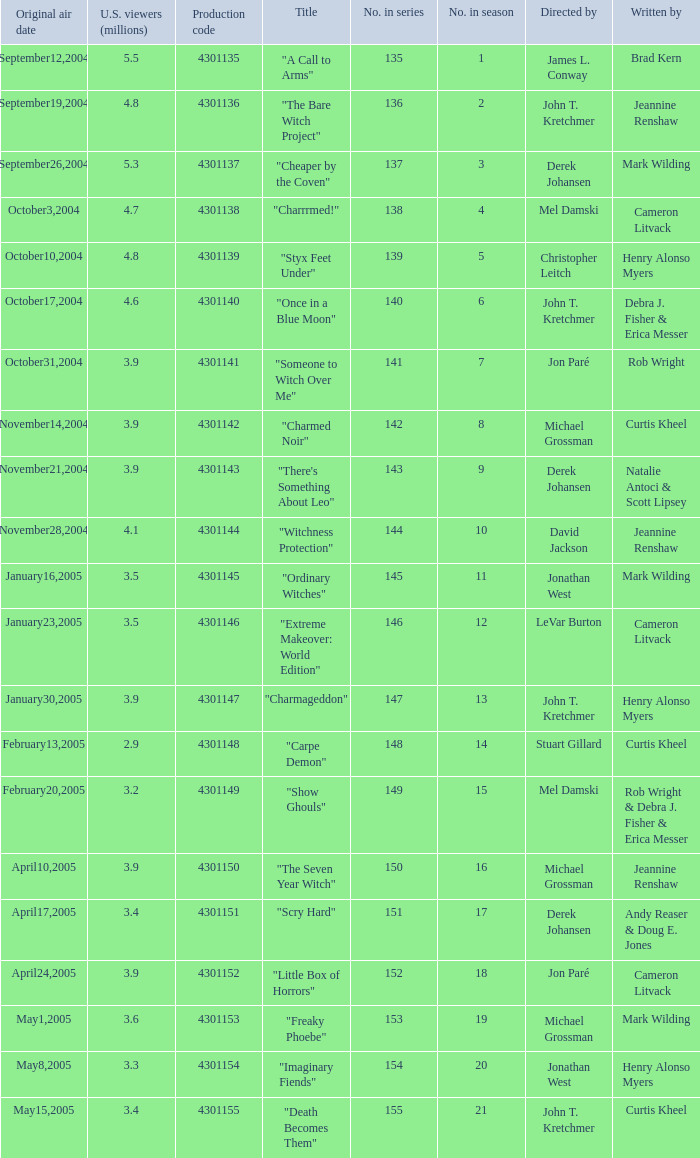What is the no in series when rob wright & debra j. fisher & erica messer were the writers? 149.0. 